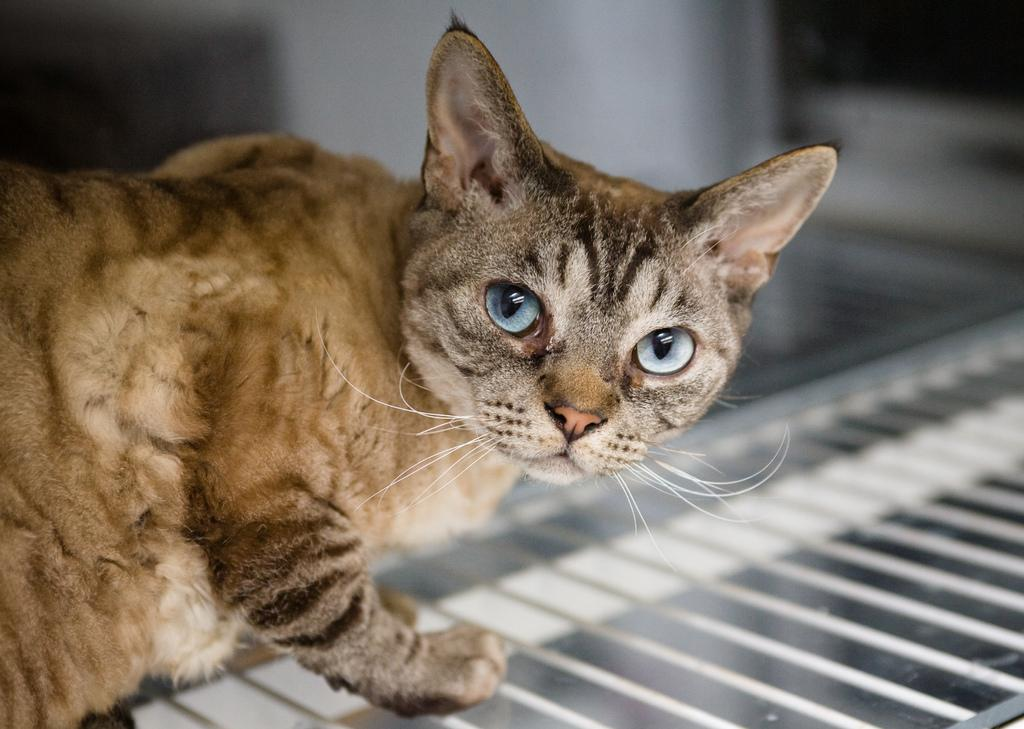What type of animal is in the image? There is a cat in the image. Can you describe the colors of the cat? The cat has brown, cream, and black colors. What is the cat sitting on in the image? The cat is on a glass surface. How would you describe the background of the image? The background of the image is blurry. What type of pain is the cat experiencing in the image? There is no indication in the image that the cat is experiencing any pain. 